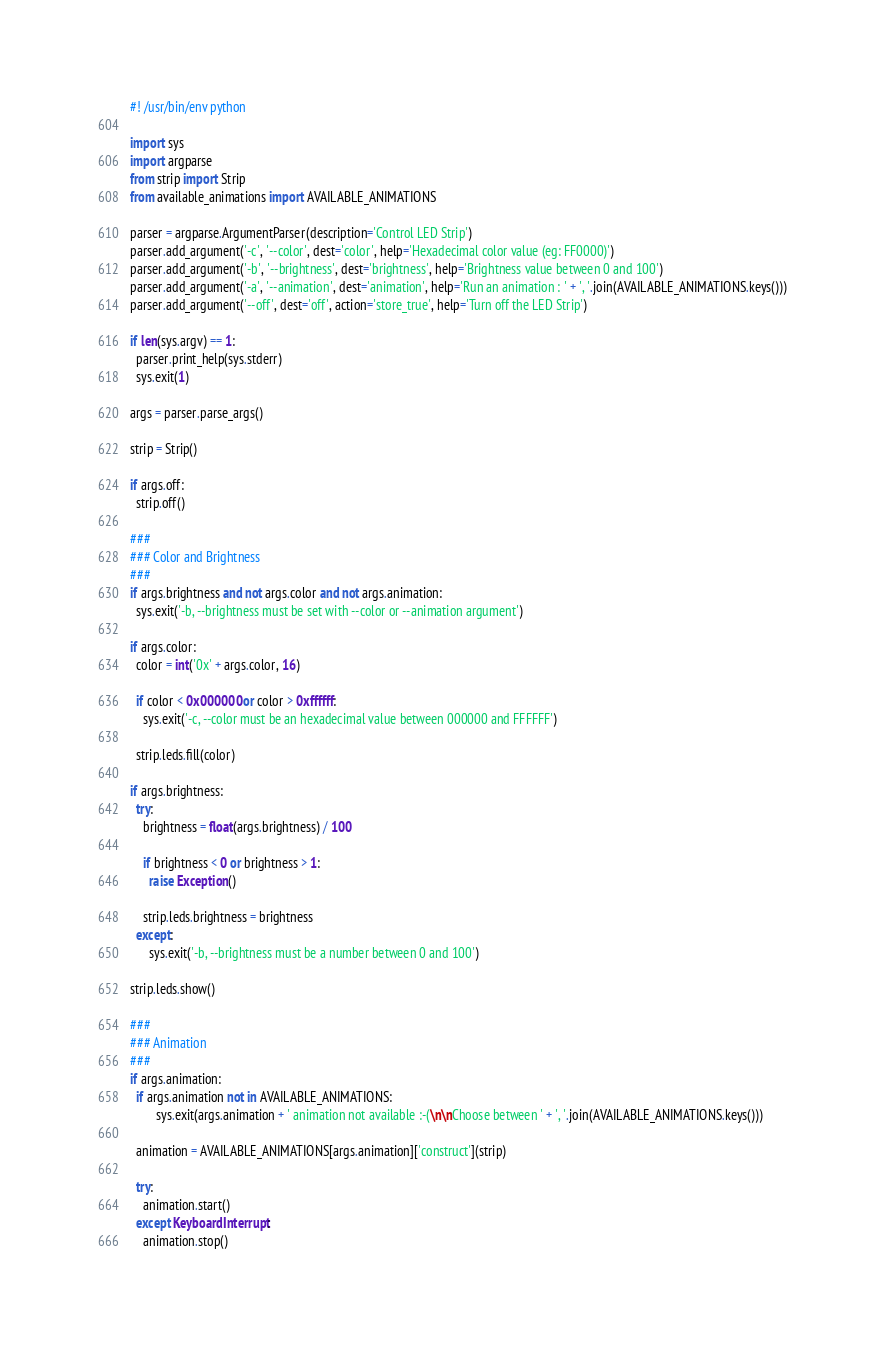<code> <loc_0><loc_0><loc_500><loc_500><_Python_>#! /usr/bin/env python

import sys
import argparse
from strip import Strip
from available_animations import AVAILABLE_ANIMATIONS

parser = argparse.ArgumentParser(description='Control LED Strip')
parser.add_argument('-c', '--color', dest='color', help='Hexadecimal color value (eg: FF0000)')
parser.add_argument('-b', '--brightness', dest='brightness', help='Brightness value between 0 and 100')
parser.add_argument('-a', '--animation', dest='animation', help='Run an animation : ' + ', '.join(AVAILABLE_ANIMATIONS.keys()))
parser.add_argument('--off', dest='off', action='store_true', help='Turn off the LED Strip')

if len(sys.argv) == 1:
  parser.print_help(sys.stderr)
  sys.exit(1)

args = parser.parse_args()

strip = Strip()

if args.off:
  strip.off()

###
### Color and Brightness
###
if args.brightness and not args.color and not args.animation:
  sys.exit('-b, --brightness must be set with --color or --animation argument')

if args.color:
  color = int('0x' + args.color, 16)

  if color < 0x000000 or color > 0xffffff:
    sys.exit('-c, --color must be an hexadecimal value between 000000 and FFFFFF')

  strip.leds.fill(color)

if args.brightness:
  try:
    brightness = float(args.brightness) / 100

    if brightness < 0 or brightness > 1:
      raise Exception()

    strip.leds.brightness = brightness
  except:
      sys.exit('-b, --brightness must be a number between 0 and 100')

strip.leds.show()

###
### Animation
###
if args.animation:
  if args.animation not in AVAILABLE_ANIMATIONS:
        sys.exit(args.animation + ' animation not available :-(\n\nChoose between ' + ', '.join(AVAILABLE_ANIMATIONS.keys()))

  animation = AVAILABLE_ANIMATIONS[args.animation]['construct'](strip)

  try:
    animation.start()
  except KeyboardInterrupt:
    animation.stop()</code> 